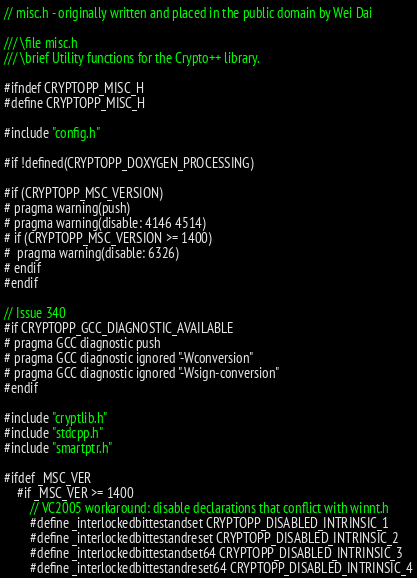<code> <loc_0><loc_0><loc_500><loc_500><_C_>// misc.h - originally written and placed in the public domain by Wei Dai

/// \file misc.h
/// \brief Utility functions for the Crypto++ library.

#ifndef CRYPTOPP_MISC_H
#define CRYPTOPP_MISC_H

#include "config.h"

#if !defined(CRYPTOPP_DOXYGEN_PROCESSING)

#if (CRYPTOPP_MSC_VERSION)
# pragma warning(push)
# pragma warning(disable: 4146 4514)
# if (CRYPTOPP_MSC_VERSION >= 1400)
#  pragma warning(disable: 6326)
# endif
#endif

// Issue 340
#if CRYPTOPP_GCC_DIAGNOSTIC_AVAILABLE
# pragma GCC diagnostic push
# pragma GCC diagnostic ignored "-Wconversion"
# pragma GCC diagnostic ignored "-Wsign-conversion"
#endif

#include "cryptlib.h"
#include "stdcpp.h"
#include "smartptr.h"

#ifdef _MSC_VER
	#if _MSC_VER >= 1400
		// VC2005 workaround: disable declarations that conflict with winnt.h
		#define _interlockedbittestandset CRYPTOPP_DISABLED_INTRINSIC_1
		#define _interlockedbittestandreset CRYPTOPP_DISABLED_INTRINSIC_2
		#define _interlockedbittestandset64 CRYPTOPP_DISABLED_INTRINSIC_3
		#define _interlockedbittestandreset64 CRYPTOPP_DISABLED_INTRINSIC_4</code> 